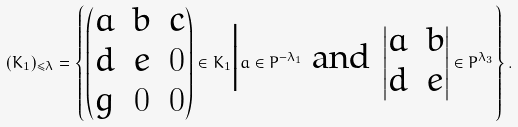<formula> <loc_0><loc_0><loc_500><loc_500>( K _ { 1 } ) _ { \leq \lambda } = \left \{ \begin{pmatrix} a & b & c \\ d & e & 0 \\ g & 0 & 0 \end{pmatrix} \in K _ { 1 } \Big | a \in P ^ { - \lambda _ { 1 } } \ \text {and} \ \begin{vmatrix} a & b \\ d & e \end{vmatrix} \in P ^ { \lambda _ { 3 } } \right \} .</formula> 